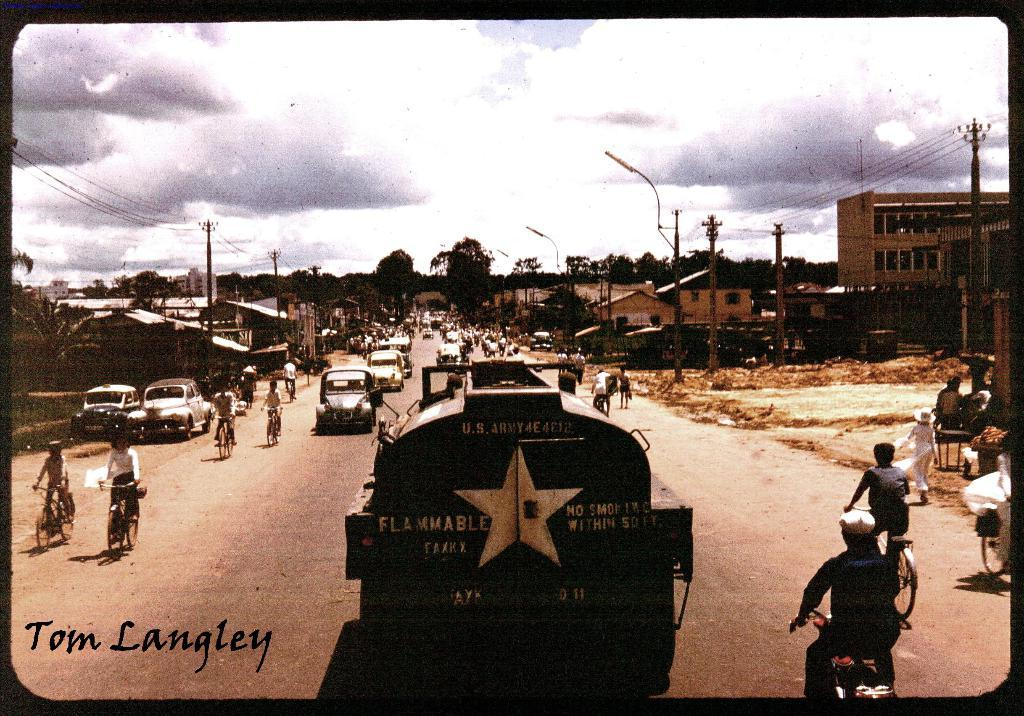Provide a one-sentence caption for the provided image. An old city with lots of bikes and a gas truck that says Flammable. 